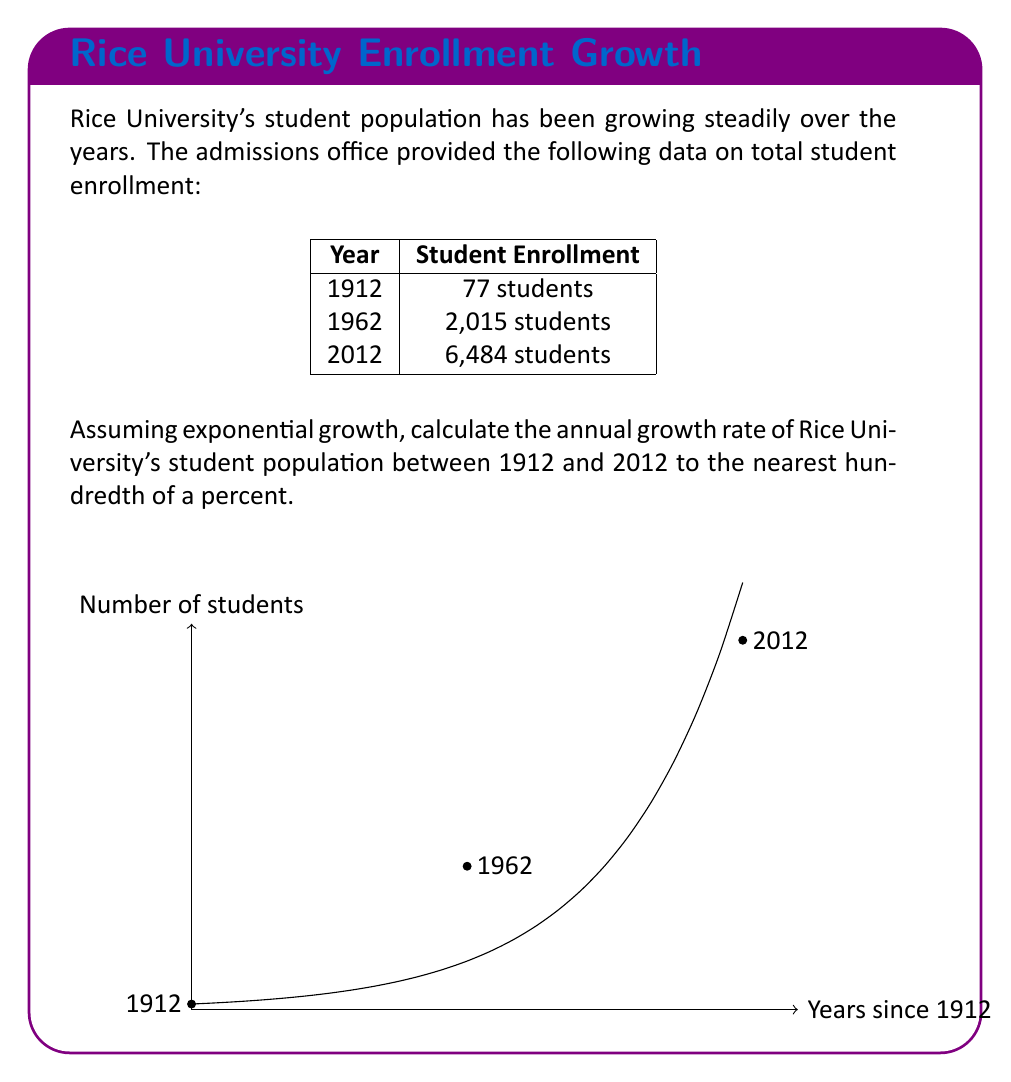Provide a solution to this math problem. To solve this problem, we'll use the exponential growth formula:

$$A = P(1 + r)^t$$

Where:
$A$ is the final amount
$P$ is the initial amount
$r$ is the annual growth rate (in decimal form)
$t$ is the time period in years

Given:
$P = 77$ (students in 1912)
$A = 6,484$ (students in 2012)
$t = 100$ years

Step 1: Plug the values into the formula:
$$6,484 = 77(1 + r)^{100}$$

Step 2: Divide both sides by 77:
$$\frac{6,484}{77} = (1 + r)^{100}$$

Step 3: Take the 100th root of both sides:
$$\sqrt[100]{\frac{6,484}{77}} = 1 + r$$

Step 4: Subtract 1 from both sides:
$$\sqrt[100]{\frac{6,484}{77}} - 1 = r$$

Step 5: Calculate the value:
$$r = \sqrt[100]{84.2077922} - 1 = 1.0445 - 1 = 0.0445$$

Step 6: Convert to a percentage:
$$0.0445 \times 100 = 4.45\%$$

Therefore, the annual growth rate of Rice University's student population between 1912 and 2012 is approximately 4.45%.
Answer: 4.45% 